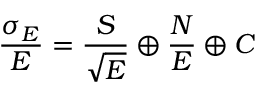<formula> <loc_0><loc_0><loc_500><loc_500>\frac { \sigma _ { E } } { E } = \frac { S } { \sqrt { E } } \oplus \frac { N } { E } \oplus C</formula> 